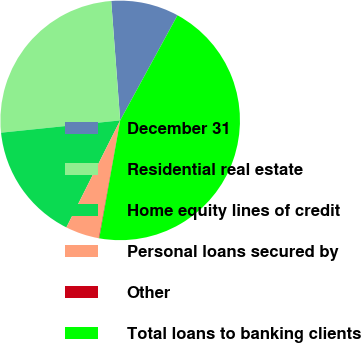<chart> <loc_0><loc_0><loc_500><loc_500><pie_chart><fcel>December 31<fcel>Residential real estate<fcel>Home equity lines of credit<fcel>Personal loans secured by<fcel>Other<fcel>Total loans to banking clients<nl><fcel>9.14%<fcel>25.44%<fcel>15.95%<fcel>4.55%<fcel>0.07%<fcel>44.84%<nl></chart> 